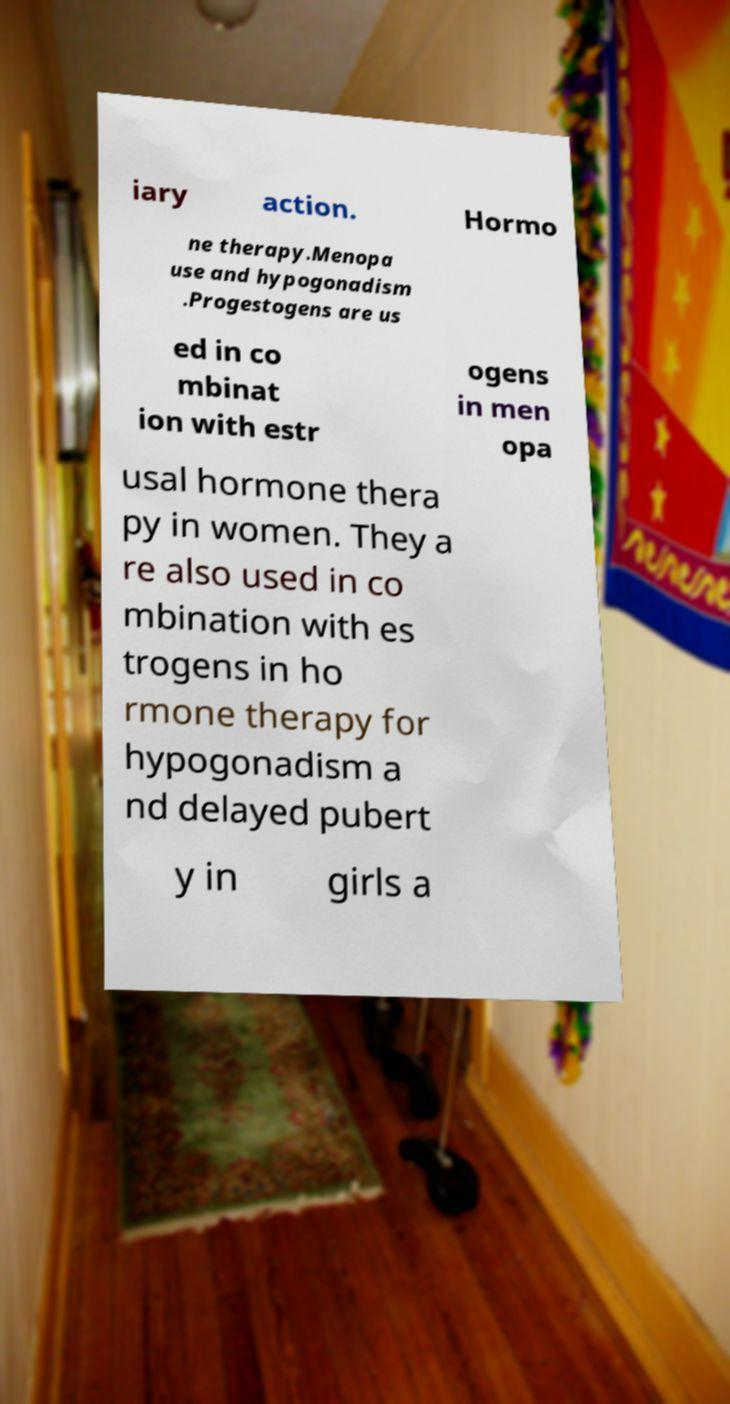Please identify and transcribe the text found in this image. iary action. Hormo ne therapy.Menopa use and hypogonadism .Progestogens are us ed in co mbinat ion with estr ogens in men opa usal hormone thera py in women. They a re also used in co mbination with es trogens in ho rmone therapy for hypogonadism a nd delayed pubert y in girls a 